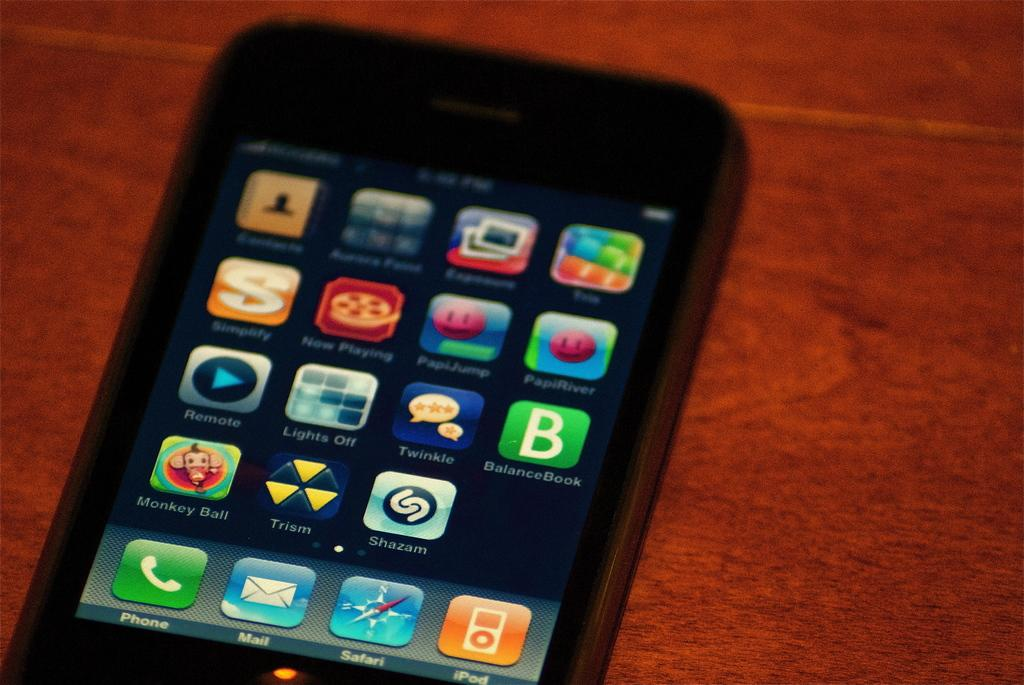<image>
Summarize the visual content of the image. A phone has many installed apps including games like Monkey Ball and PapiJump. 